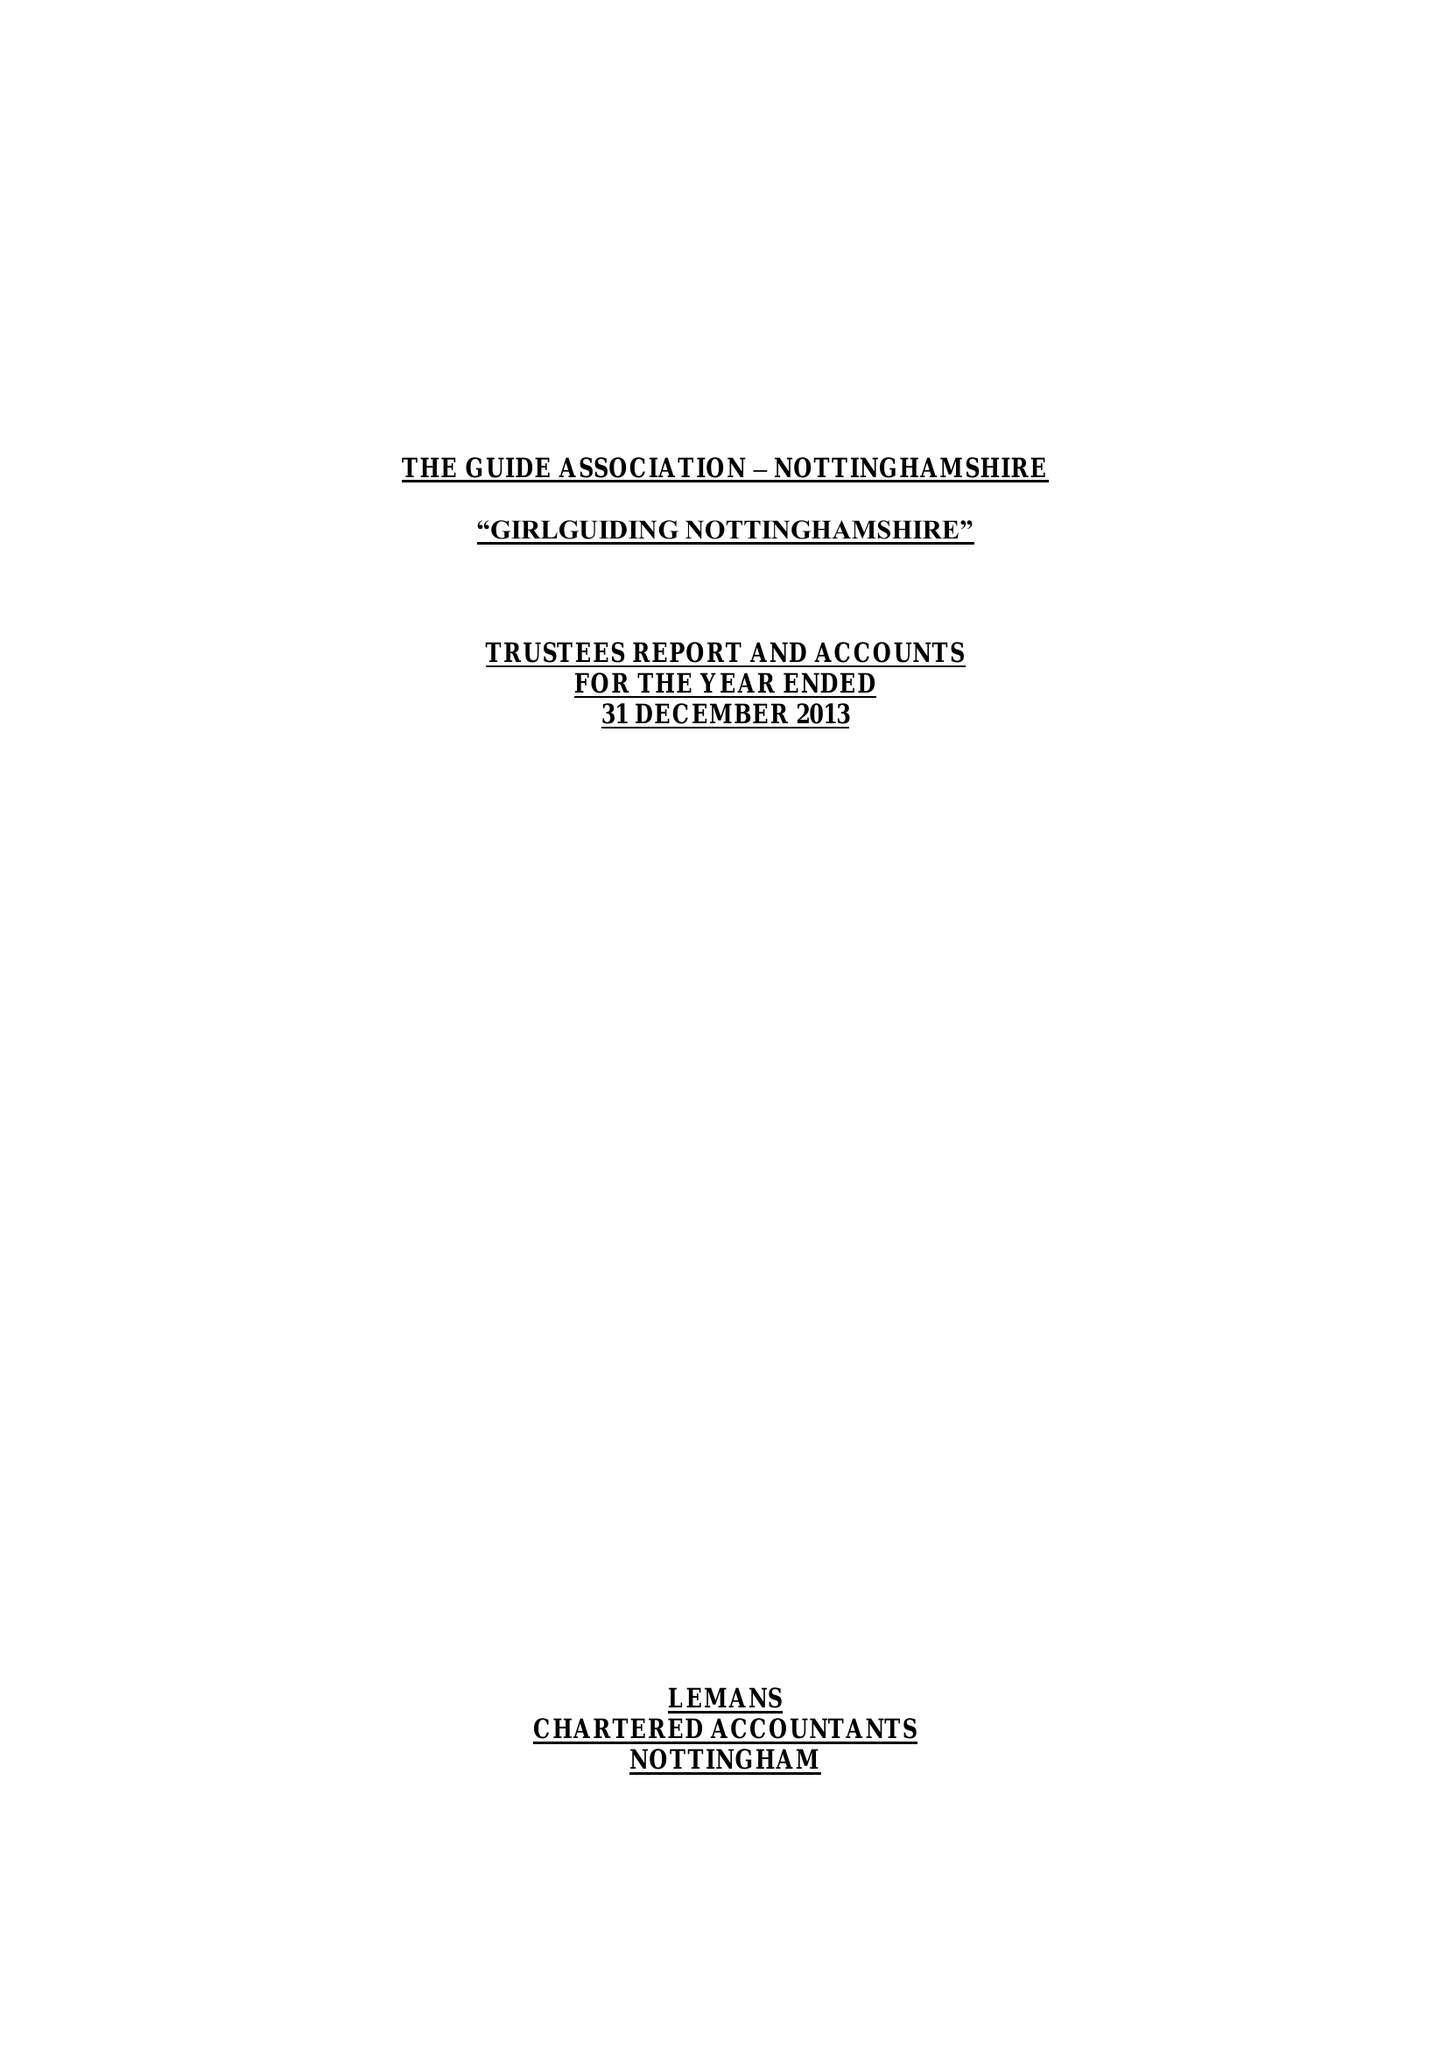What is the value for the report_date?
Answer the question using a single word or phrase. 2013-12-31 